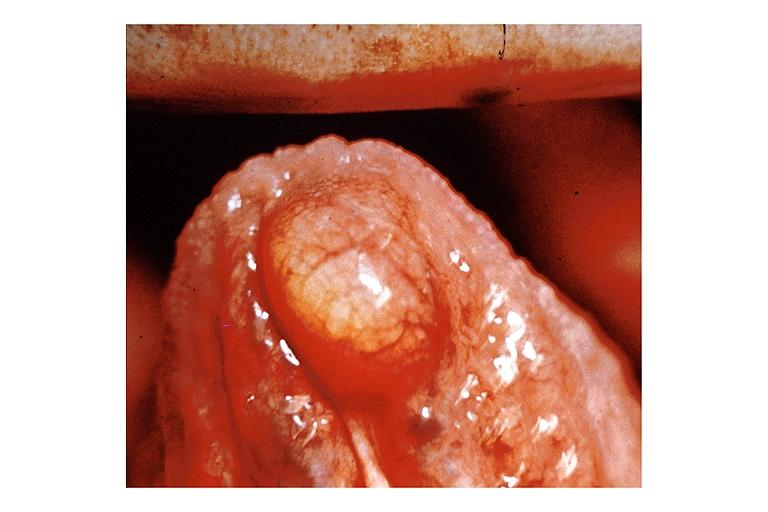s cervical carcinoma present?
Answer the question using a single word or phrase. No 